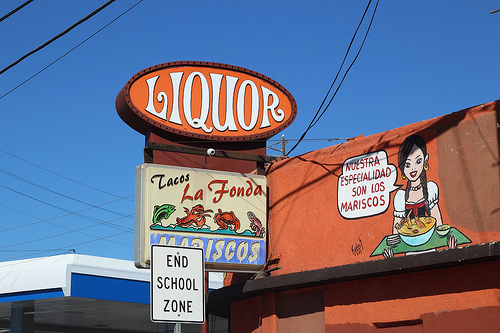<image>
Is there a sign board under the logo? Yes. The sign board is positioned underneath the logo, with the logo above it in the vertical space. Is there a sign in front of the building? Yes. The sign is positioned in front of the building, appearing closer to the camera viewpoint. 